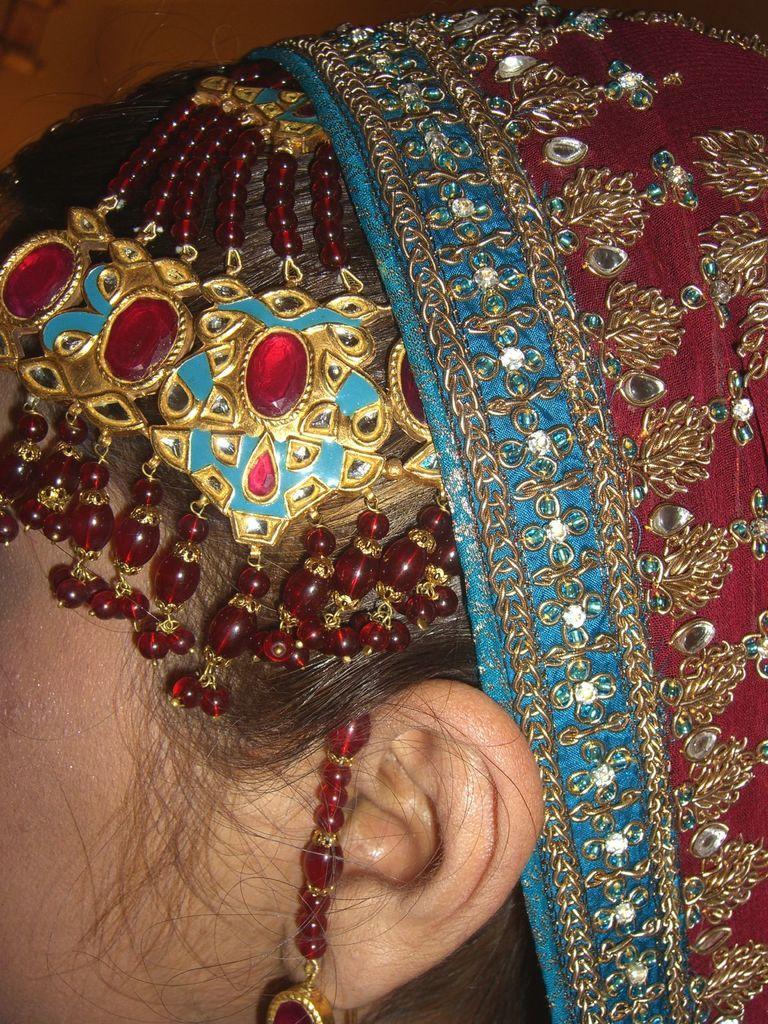Can you describe this image briefly? In this image we can see the head of a woman. 